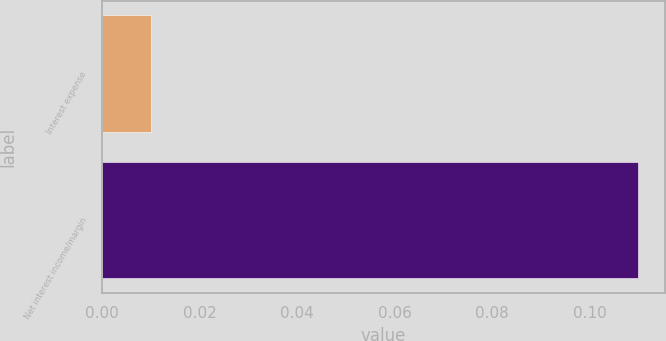Convert chart to OTSL. <chart><loc_0><loc_0><loc_500><loc_500><bar_chart><fcel>Interest expense<fcel>Net interest income/margin<nl><fcel>0.01<fcel>0.11<nl></chart> 